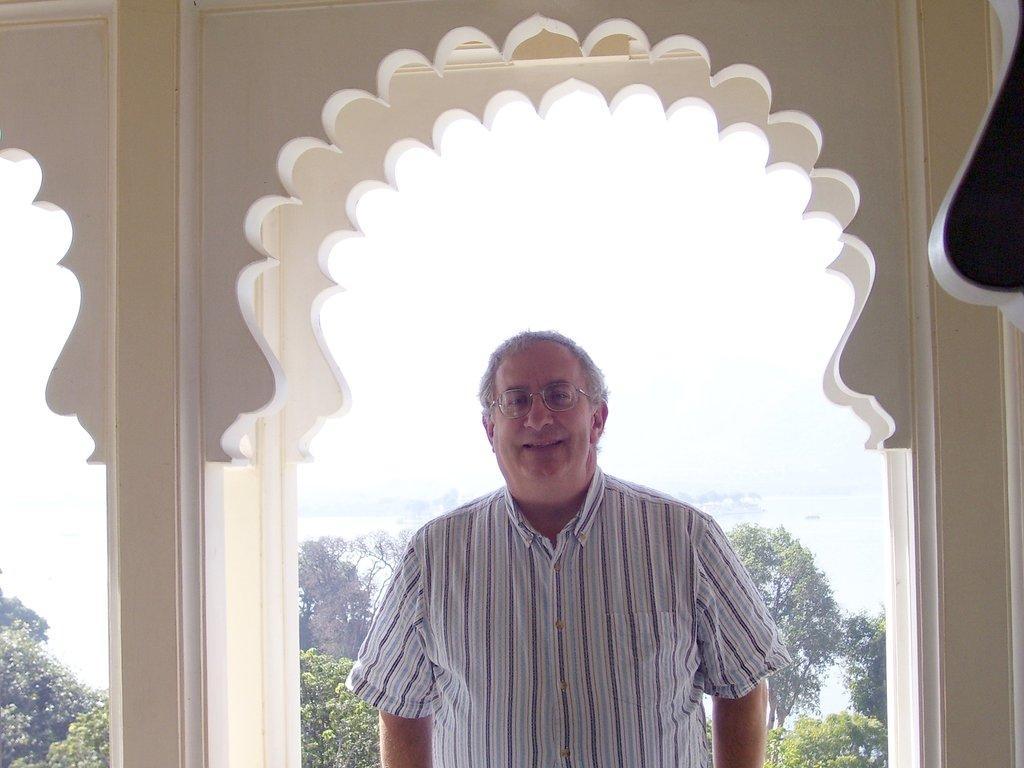In one or two sentences, can you explain what this image depicts? The picture is taken in a building. In the foreground of the picture there is a man standing, he is smiling. Behind him there is wall. In the center of the picture there are trees and water. It is sunny. 